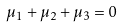Convert formula to latex. <formula><loc_0><loc_0><loc_500><loc_500>\mu _ { 1 } + \mu _ { 2 } + \mu _ { 3 } = 0</formula> 